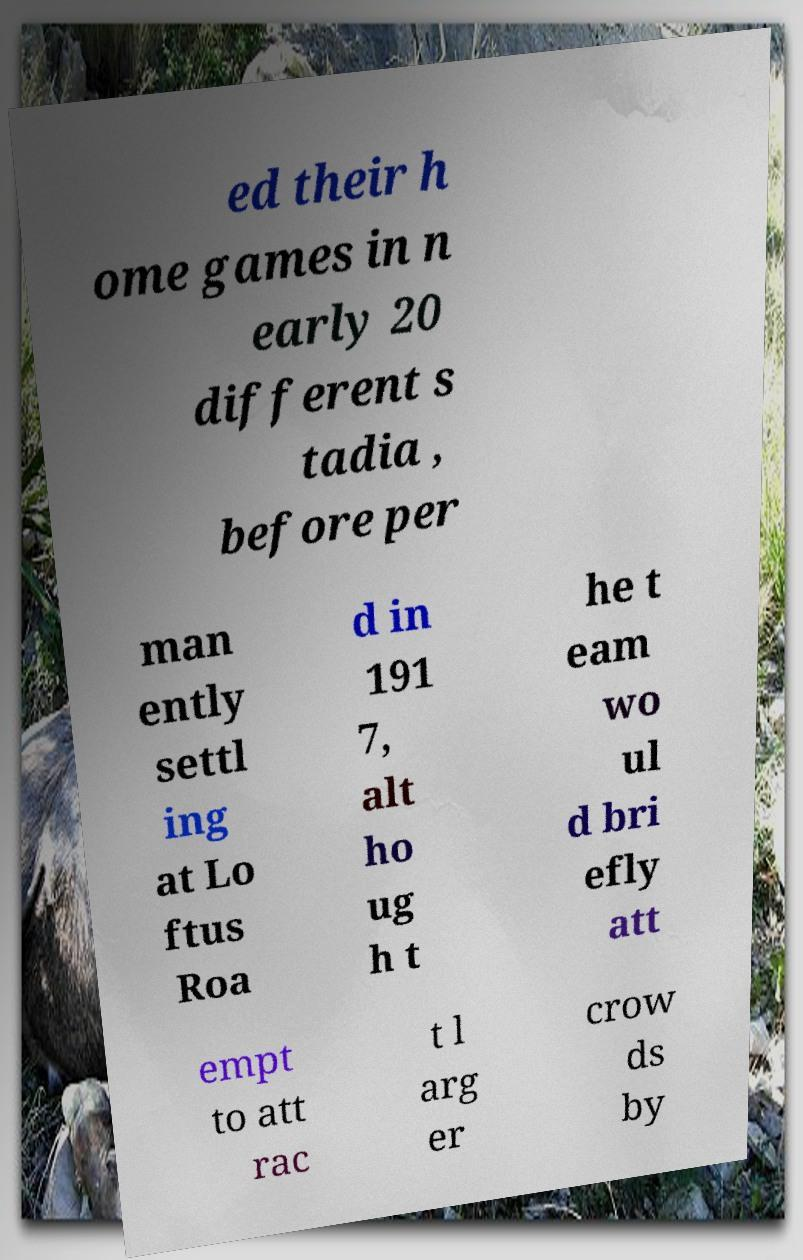For documentation purposes, I need the text within this image transcribed. Could you provide that? ed their h ome games in n early 20 different s tadia , before per man ently settl ing at Lo ftus Roa d in 191 7, alt ho ug h t he t eam wo ul d bri efly att empt to att rac t l arg er crow ds by 